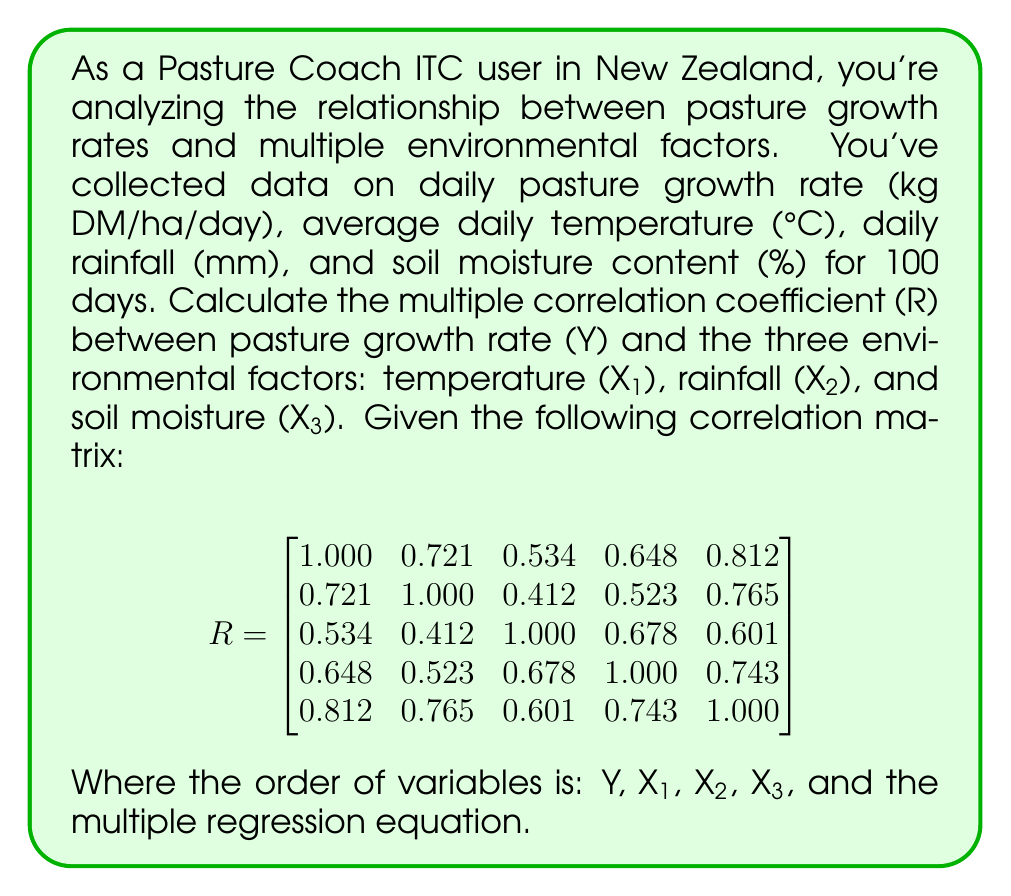Show me your answer to this math problem. To calculate the multiple correlation coefficient (R) between pasture growth rate (Y) and the three environmental factors (X₁, X₂, X₃), we'll use the following steps:

1. Identify the necessary correlation coefficients from the given matrix:
   $r_{Y1} = 0.721$ (correlation between Y and X₁)
   $r_{Y2} = 0.534$ (correlation between Y and X₂)
   $r_{Y3} = 0.648$ (correlation between Y and X₃)
   $r_{12} = 0.412$ (correlation between X₁ and X₂)
   $r_{13} = 0.523$ (correlation between X₁ and X₃)
   $r_{23} = 0.678$ (correlation between X₂ and X₃)

2. Calculate the multiple correlation coefficient using the formula:

   $$R = \sqrt{\frac{r_{Y1}^2 + r_{Y2}^2 + r_{Y3}^2 - 2r_{Y1}r_{Y2}r_{12} - 2r_{Y1}r_{Y3}r_{13} - 2r_{Y2}r_{Y3}r_{23} + 2r_{Y1}r_{Y2}r_{Y3}}{1 - r_{12}^2 - r_{13}^2 - r_{23}^2 + 2r_{12}r_{13}r_{23}}}$$

3. Substitute the values:

   $$R = \sqrt{\frac{0.721^2 + 0.534^2 + 0.648^2 - 2(0.721)(0.534)(0.412) - 2(0.721)(0.648)(0.523) - 2(0.534)(0.648)(0.678) + 2(0.721)(0.534)(0.648)}{1 - 0.412^2 - 0.523^2 - 0.678^2 + 2(0.412)(0.523)(0.678)}}$$

4. Calculate the numerator and denominator separately:

   Numerator: $0.519841 + 0.285156 + 0.419904 - 0.317034 - 0.489030 - 0.465670 + 0.498550 = 0.451717$
   
   Denominator: $1 - 0.169744 - 0.273529 - 0.459684 + 0.291386 = 0.388429$

5. Divide the numerator by the denominator and take the square root:

   $$R = \sqrt{\frac{0.451717}{0.388429}} = \sqrt{1.163185} = 1.078510$$

The multiple correlation coefficient (R) is approximately 1.0785.
Answer: $R \approx 1.0785$ 